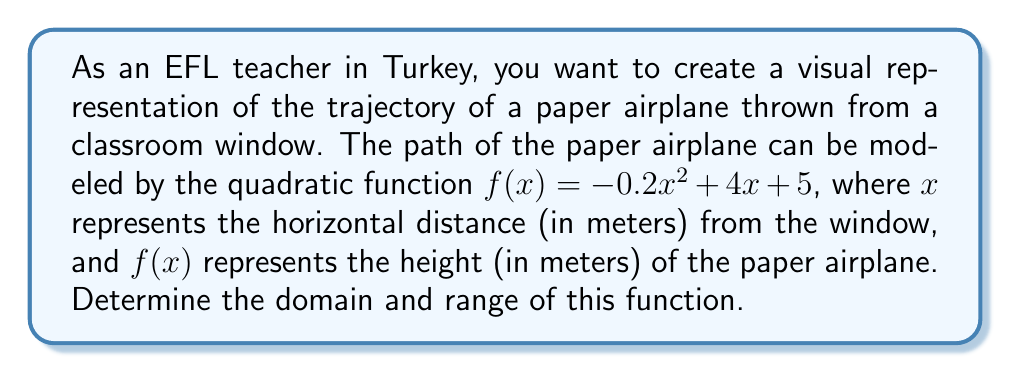Provide a solution to this math problem. Let's approach this step-by-step:

1) Domain:
   - The domain represents all possible x-values (horizontal distances) for which the function is defined.
   - For a quadratic function, the domain is typically all real numbers unless there are specific restrictions.
   - In this context, $x$ represents distance, which cannot be negative.
   - Therefore, the domain is $x \geq 0$.

2) Range:
   - To find the range, we need to determine the vertex of the parabola.
   - The general form of a quadratic function is $f(x) = ax^2 + bx + c$
   - Here, $a = -0.2$, $b = 4$, and $c = 5$

   - The x-coordinate of the vertex is given by $x = -\frac{b}{2a}$:
     $x = -\frac{4}{2(-0.2)} = -\frac{4}{-0.4} = 10$

   - To find the y-coordinate, we substitute $x = 10$ into the original function:
     $f(10) = -0.2(10)^2 + 4(10) + 5$
     $= -0.2(100) + 40 + 5$
     $= -20 + 40 + 5 = 25$

   - The vertex is (10, 25), which is the highest point of the parabola.

   - Since $a$ is negative, the parabola opens downward.
   - This means the function will take on all y-values from the vertex downward.

   - The minimum y-value is 5 (when $x = 0$).

   - Therefore, the range is $5 \leq y \leq 25$.
Answer: Domain: $x \geq 0$, Range: $5 \leq y \leq 25$ 